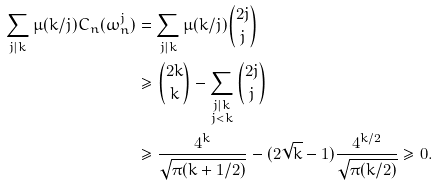Convert formula to latex. <formula><loc_0><loc_0><loc_500><loc_500>\sum _ { j | k } \mu ( k / j ) C _ { n } ( \omega _ { n } ^ { j } ) & = \sum _ { j | k } \mu ( k / j ) \binom { 2 j } { j } \\ & \geq \binom { 2 k } { k } - \sum _ { \substack { j | k \\ j < k } } \binom { 2 j } { j } \\ & \geq \frac { 4 ^ { k } } { \sqrt { \pi ( k + 1 / 2 ) } } - ( 2 \sqrt { k } - 1 ) \frac { 4 ^ { k / 2 } } { \sqrt { \pi ( k / 2 ) } } \geq 0 .</formula> 